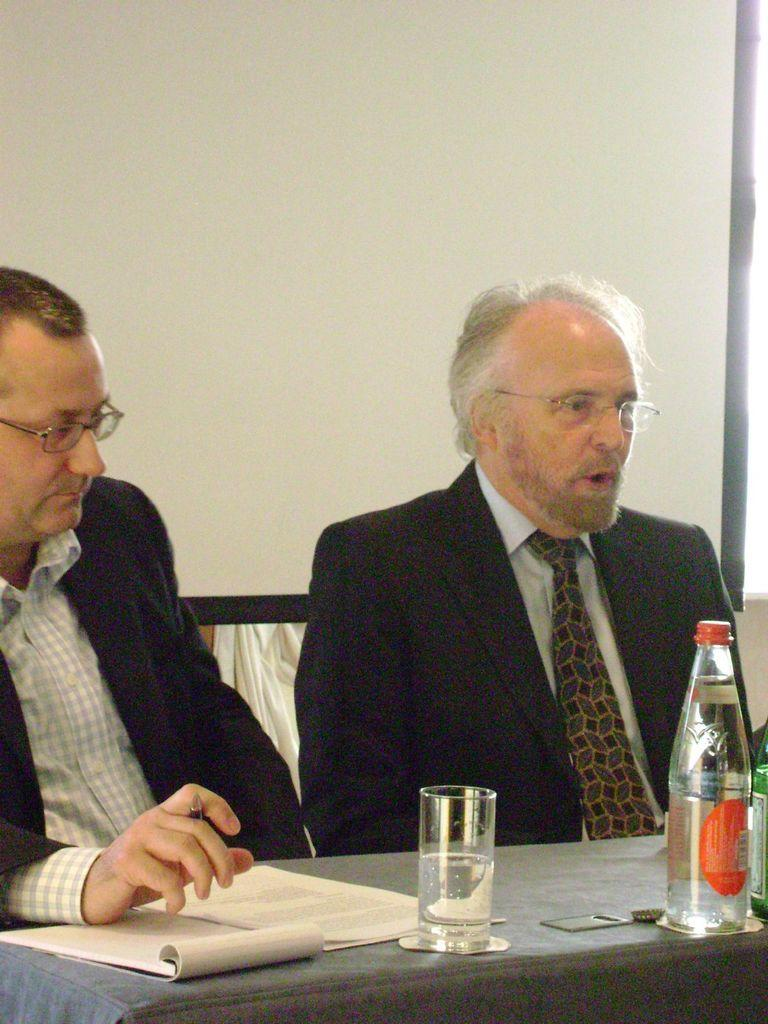How many people are in the image? There are two persons in the image. What are the two persons wearing? Both persons are wearing clothes and spectacles. What is in front of the two persons? There is a table in front of the two persons. What items can be seen on the table? The table contains a notebook, a glass, and a water bottle. What is one person holding? One person is holding a pen. Can you see any tickets or stamps on the table in the image? No, there are no tickets or stamps visible on the table in the image. Is this image taken at an airport? The provided facts do not mention anything about an airport, so we cannot determine if the image was taken there. 